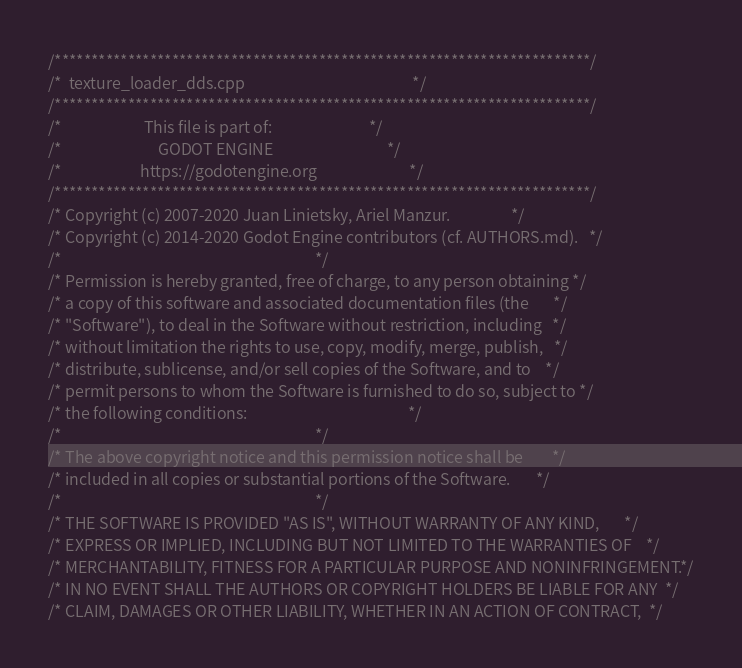Convert code to text. <code><loc_0><loc_0><loc_500><loc_500><_C++_>/*************************************************************************/
/*  texture_loader_dds.cpp                                               */
/*************************************************************************/
/*                       This file is part of:                           */
/*                           GODOT ENGINE                                */
/*                      https://godotengine.org                          */
/*************************************************************************/
/* Copyright (c) 2007-2020 Juan Linietsky, Ariel Manzur.                 */
/* Copyright (c) 2014-2020 Godot Engine contributors (cf. AUTHORS.md).   */
/*                                                                       */
/* Permission is hereby granted, free of charge, to any person obtaining */
/* a copy of this software and associated documentation files (the       */
/* "Software"), to deal in the Software without restriction, including   */
/* without limitation the rights to use, copy, modify, merge, publish,   */
/* distribute, sublicense, and/or sell copies of the Software, and to    */
/* permit persons to whom the Software is furnished to do so, subject to */
/* the following conditions:                                             */
/*                                                                       */
/* The above copyright notice and this permission notice shall be        */
/* included in all copies or substantial portions of the Software.       */
/*                                                                       */
/* THE SOFTWARE IS PROVIDED "AS IS", WITHOUT WARRANTY OF ANY KIND,       */
/* EXPRESS OR IMPLIED, INCLUDING BUT NOT LIMITED TO THE WARRANTIES OF    */
/* MERCHANTABILITY, FITNESS FOR A PARTICULAR PURPOSE AND NONINFRINGEMENT.*/
/* IN NO EVENT SHALL THE AUTHORS OR COPYRIGHT HOLDERS BE LIABLE FOR ANY  */
/* CLAIM, DAMAGES OR OTHER LIABILITY, WHETHER IN AN ACTION OF CONTRACT,  */</code> 